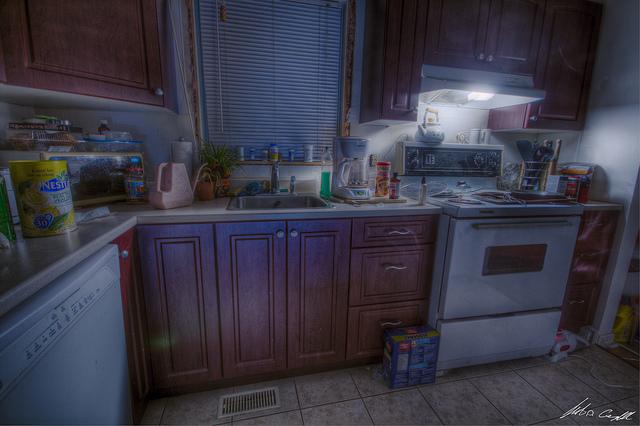What pattern is the pot in the upper right corner?
Be succinct. Solid. What is in the big yellow canister on the counter?
Quick response, please. Corn. Is it daytime?
Give a very brief answer. No. Is the light on or off?
Keep it brief. On. Where is the cup located?
Concise answer only. Counter. What kind of stove is pictured?
Give a very brief answer. Electric. Is there a dishwasher in this photo?
Write a very short answer. Yes. Why is there bottles on the counter?
Concise answer only. Recyclables. Is the kitchen crowded?
Concise answer only. Yes. Is this a play kitchen?
Give a very brief answer. No. Is it dark outside in this image?
Keep it brief. Yes. What is in the jar at the end of the counter?
Answer briefly. Tea. 